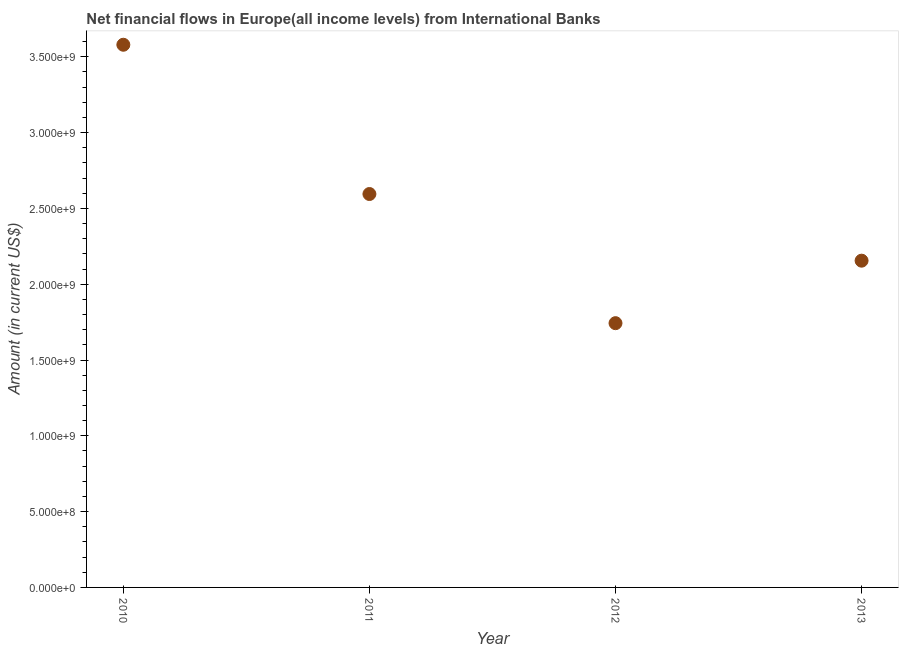What is the net financial flows from ibrd in 2011?
Your response must be concise. 2.59e+09. Across all years, what is the maximum net financial flows from ibrd?
Provide a short and direct response. 3.58e+09. Across all years, what is the minimum net financial flows from ibrd?
Keep it short and to the point. 1.74e+09. In which year was the net financial flows from ibrd minimum?
Your answer should be compact. 2012. What is the sum of the net financial flows from ibrd?
Provide a short and direct response. 1.01e+1. What is the difference between the net financial flows from ibrd in 2011 and 2013?
Offer a very short reply. 4.40e+08. What is the average net financial flows from ibrd per year?
Keep it short and to the point. 2.52e+09. What is the median net financial flows from ibrd?
Offer a very short reply. 2.37e+09. In how many years, is the net financial flows from ibrd greater than 3200000000 US$?
Your answer should be very brief. 1. Do a majority of the years between 2012 and 2010 (inclusive) have net financial flows from ibrd greater than 1400000000 US$?
Ensure brevity in your answer.  No. What is the ratio of the net financial flows from ibrd in 2010 to that in 2012?
Make the answer very short. 2.05. Is the difference between the net financial flows from ibrd in 2012 and 2013 greater than the difference between any two years?
Keep it short and to the point. No. What is the difference between the highest and the second highest net financial flows from ibrd?
Keep it short and to the point. 9.85e+08. What is the difference between the highest and the lowest net financial flows from ibrd?
Your answer should be very brief. 1.84e+09. In how many years, is the net financial flows from ibrd greater than the average net financial flows from ibrd taken over all years?
Offer a terse response. 2. Does the net financial flows from ibrd monotonically increase over the years?
Your response must be concise. No. Does the graph contain grids?
Provide a short and direct response. No. What is the title of the graph?
Provide a short and direct response. Net financial flows in Europe(all income levels) from International Banks. What is the Amount (in current US$) in 2010?
Provide a succinct answer. 3.58e+09. What is the Amount (in current US$) in 2011?
Provide a short and direct response. 2.59e+09. What is the Amount (in current US$) in 2012?
Your answer should be very brief. 1.74e+09. What is the Amount (in current US$) in 2013?
Provide a short and direct response. 2.16e+09. What is the difference between the Amount (in current US$) in 2010 and 2011?
Your answer should be very brief. 9.85e+08. What is the difference between the Amount (in current US$) in 2010 and 2012?
Your answer should be compact. 1.84e+09. What is the difference between the Amount (in current US$) in 2010 and 2013?
Provide a succinct answer. 1.42e+09. What is the difference between the Amount (in current US$) in 2011 and 2012?
Your response must be concise. 8.52e+08. What is the difference between the Amount (in current US$) in 2011 and 2013?
Ensure brevity in your answer.  4.40e+08. What is the difference between the Amount (in current US$) in 2012 and 2013?
Offer a very short reply. -4.12e+08. What is the ratio of the Amount (in current US$) in 2010 to that in 2011?
Offer a terse response. 1.38. What is the ratio of the Amount (in current US$) in 2010 to that in 2012?
Keep it short and to the point. 2.05. What is the ratio of the Amount (in current US$) in 2010 to that in 2013?
Offer a very short reply. 1.66. What is the ratio of the Amount (in current US$) in 2011 to that in 2012?
Keep it short and to the point. 1.49. What is the ratio of the Amount (in current US$) in 2011 to that in 2013?
Give a very brief answer. 1.2. What is the ratio of the Amount (in current US$) in 2012 to that in 2013?
Provide a succinct answer. 0.81. 